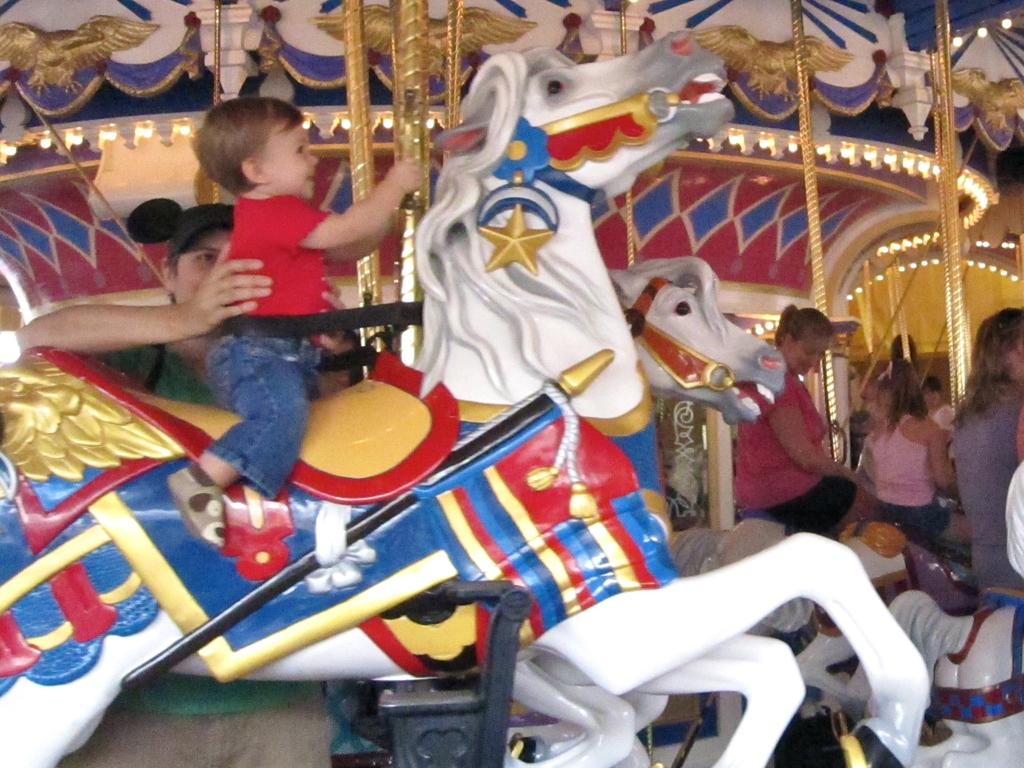How many people are in the image? There is a group of people in the image. What are some of the people doing in the image? Some people are seated on horse toys. What type of objects can be seen in the image besides the people? There are metal rods present in the image. What type of decision did the achiever make in the image? There is no mention of an achiever or a decision in the image. 